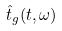Convert formula to latex. <formula><loc_0><loc_0><loc_500><loc_500>\hat { t } _ { g } ( t , \omega )</formula> 